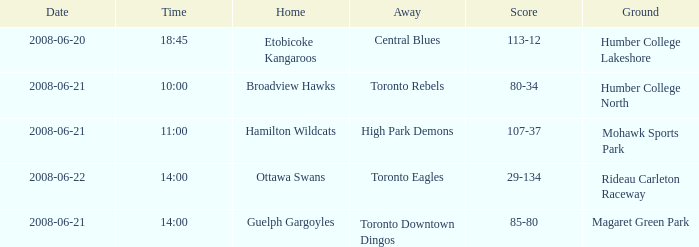What is the Ground with a Date that is 2008-06-20? Humber College Lakeshore. 